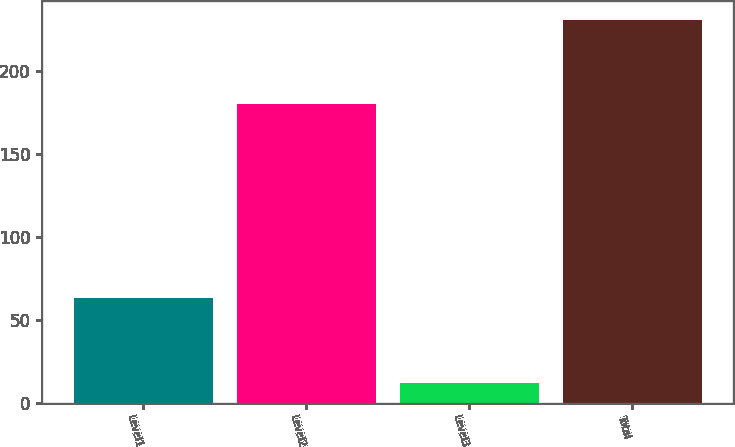<chart> <loc_0><loc_0><loc_500><loc_500><bar_chart><fcel>Level1<fcel>Level2<fcel>Level3<fcel>Total<nl><fcel>63<fcel>180<fcel>12<fcel>231<nl></chart> 